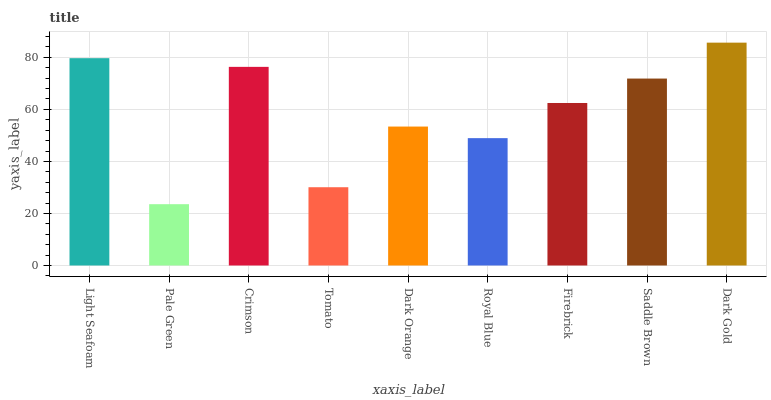Is Crimson the minimum?
Answer yes or no. No. Is Crimson the maximum?
Answer yes or no. No. Is Crimson greater than Pale Green?
Answer yes or no. Yes. Is Pale Green less than Crimson?
Answer yes or no. Yes. Is Pale Green greater than Crimson?
Answer yes or no. No. Is Crimson less than Pale Green?
Answer yes or no. No. Is Firebrick the high median?
Answer yes or no. Yes. Is Firebrick the low median?
Answer yes or no. Yes. Is Dark Gold the high median?
Answer yes or no. No. Is Pale Green the low median?
Answer yes or no. No. 